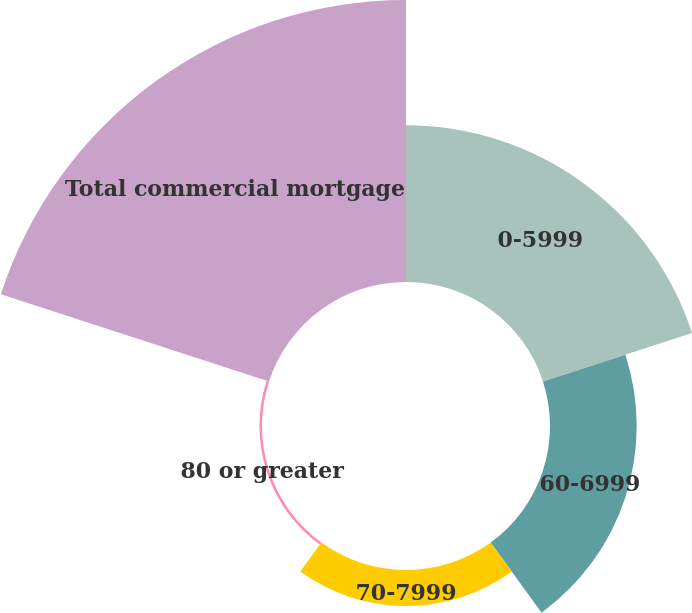Convert chart. <chart><loc_0><loc_0><loc_500><loc_500><pie_chart><fcel>0-5999<fcel>60-6999<fcel>70-7999<fcel>80 or greater<fcel>Total commercial mortgage<nl><fcel>27.8%<fcel>15.37%<fcel>6.38%<fcel>0.45%<fcel>50.0%<nl></chart> 